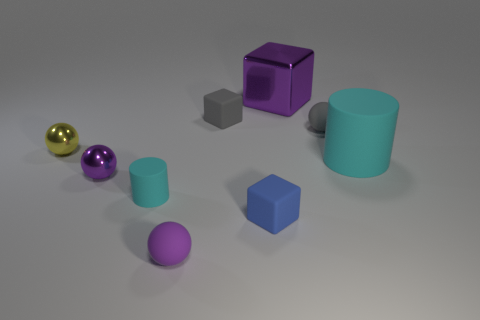Subtract 1 balls. How many balls are left? 3 Add 1 big blue shiny cylinders. How many objects exist? 10 Subtract all cubes. How many objects are left? 6 Subtract 1 blue blocks. How many objects are left? 8 Subtract all purple metal cylinders. Subtract all big objects. How many objects are left? 7 Add 7 big cubes. How many big cubes are left? 8 Add 8 tiny gray rubber cylinders. How many tiny gray rubber cylinders exist? 8 